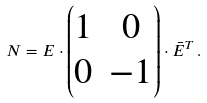<formula> <loc_0><loc_0><loc_500><loc_500>N = E \cdot \begin{pmatrix} 1 & 0 \\ 0 & - 1 \end{pmatrix} \cdot \bar { E } ^ { T } \, .</formula> 